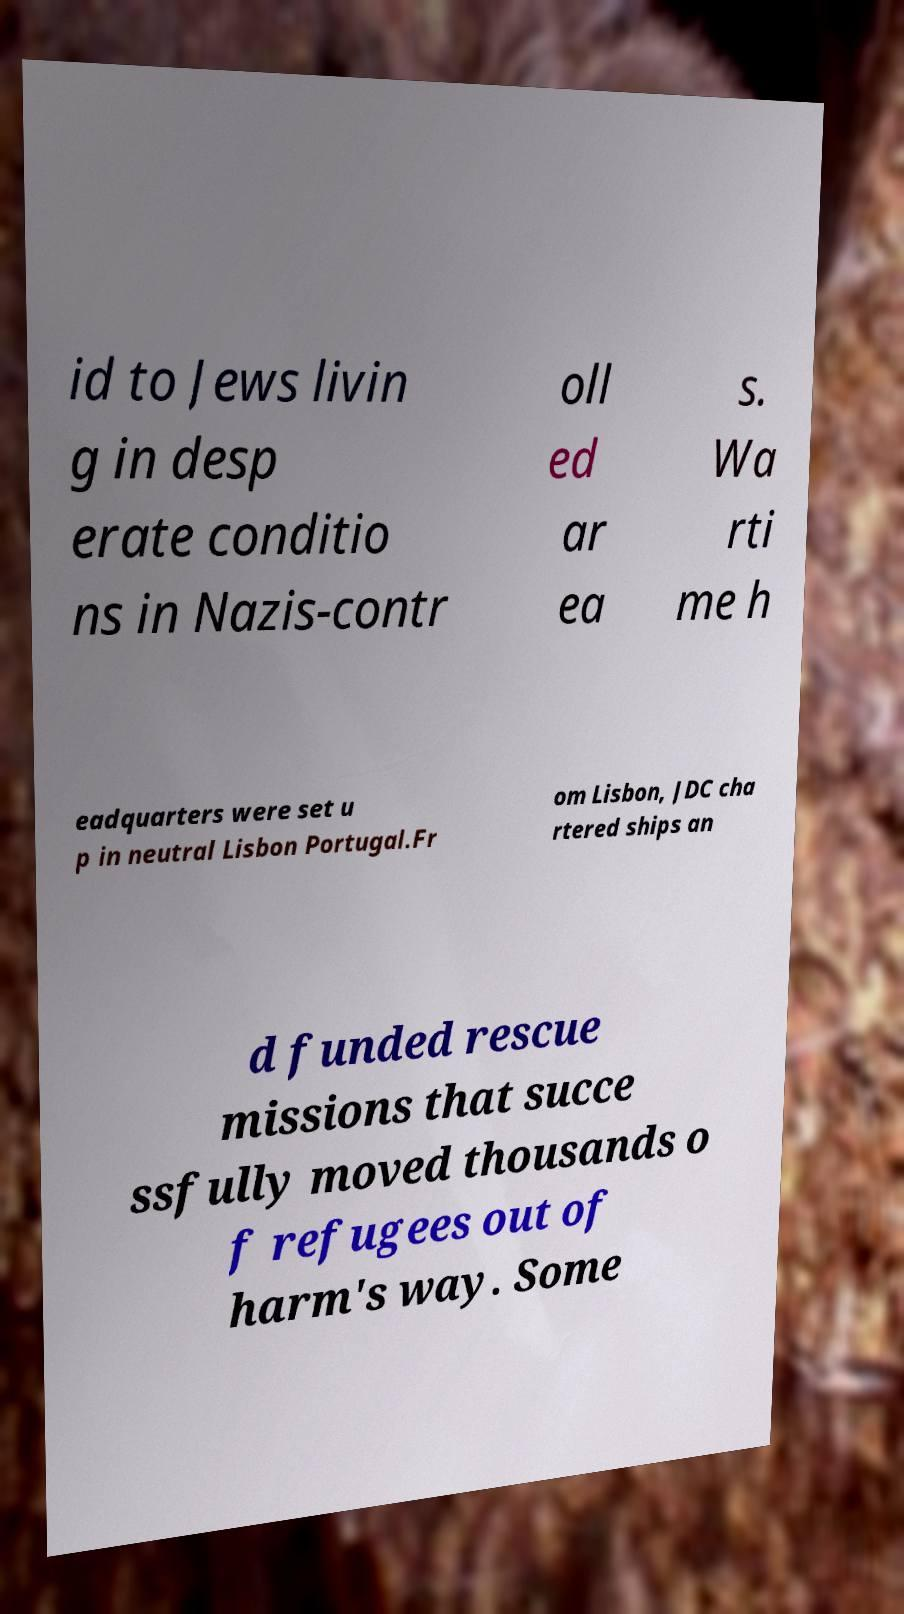For documentation purposes, I need the text within this image transcribed. Could you provide that? id to Jews livin g in desp erate conditio ns in Nazis-contr oll ed ar ea s. Wa rti me h eadquarters were set u p in neutral Lisbon Portugal.Fr om Lisbon, JDC cha rtered ships an d funded rescue missions that succe ssfully moved thousands o f refugees out of harm's way. Some 